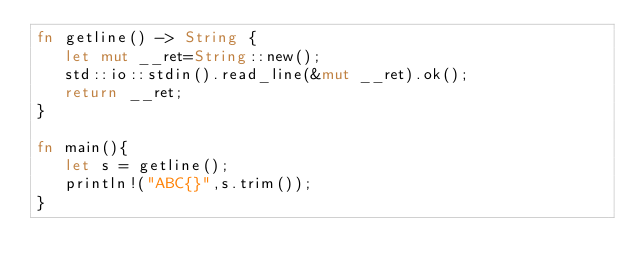Convert code to text. <code><loc_0><loc_0><loc_500><loc_500><_Rust_>fn getline() -> String {
   let mut __ret=String::new();
   std::io::stdin().read_line(&mut __ret).ok();
   return __ret;
}

fn main(){
   let s = getline();
   println!("ABC{}",s.trim());
}
</code> 